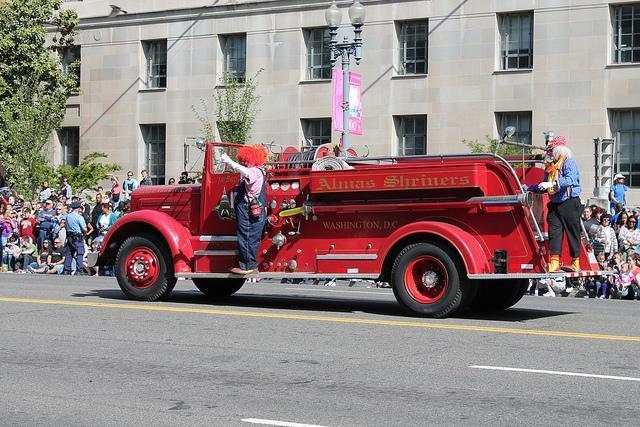How many tires does the truck have?
Give a very brief answer. 4. How many wheels are on this truck?
Give a very brief answer. 4. How many tires can you see on the truck?
Give a very brief answer. 4. How many people are there?
Give a very brief answer. 3. 